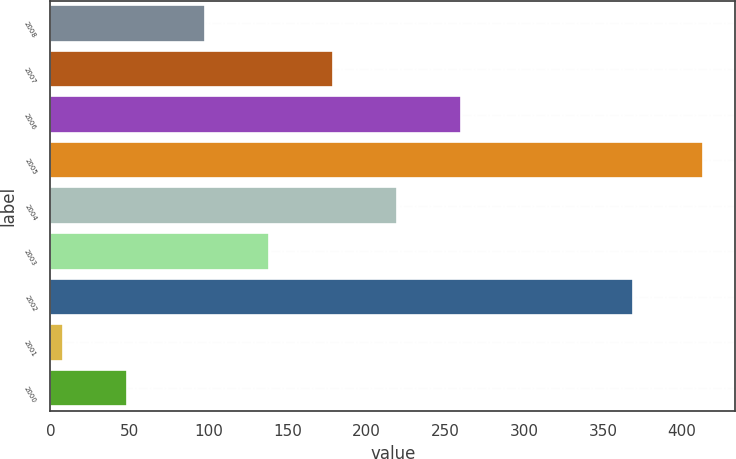Convert chart to OTSL. <chart><loc_0><loc_0><loc_500><loc_500><bar_chart><fcel>2008<fcel>2007<fcel>2006<fcel>2005<fcel>2004<fcel>2003<fcel>2002<fcel>2001<fcel>2000<nl><fcel>98<fcel>179<fcel>260<fcel>413<fcel>219.5<fcel>138.5<fcel>369<fcel>8<fcel>48.5<nl></chart> 